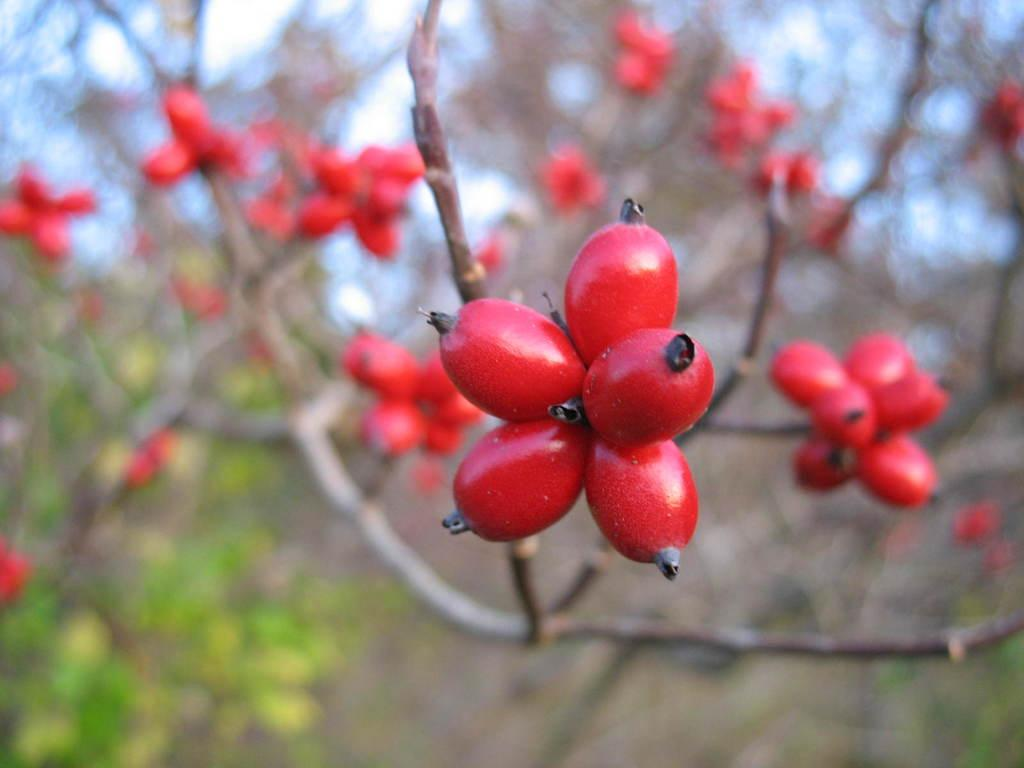What type of fruits are in the image? There are rose hip fruits in the image. Where are the rose hip fruits located? The rose hip fruits are on a tree branch. How is the background of the image depicted? The background of the rose hip fruits is blurred. What type of toy can be seen rolling in a circle in the image? There is no toy present in the image, and therefore no such activity can be observed. How many marbles are visible in the image? There are no marbles present in the image. 